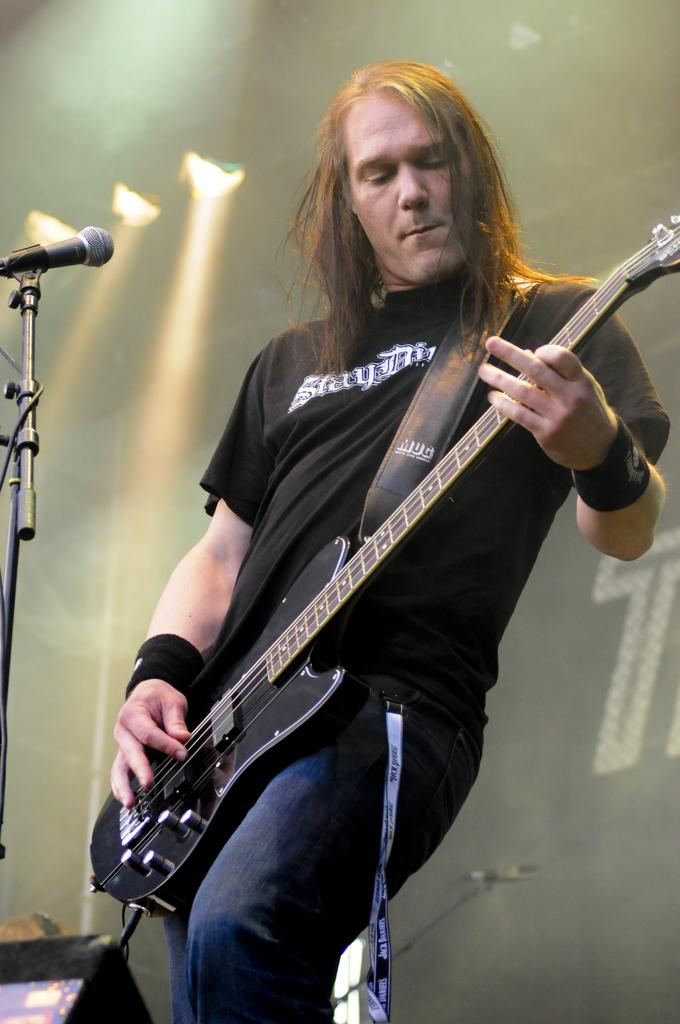Who is the person in the image? There is a man in the image. What is the man doing in the image? The man is playing a guitar. What object is present for amplifying sound in the image? There is a microphone in the image. What can be seen in the background of the image? There are lights in the background of the image. What type of door can be seen being destroyed in the image? There is no door or destruction present in the image; it features a man playing a guitar with a microphone and lights in the background. 